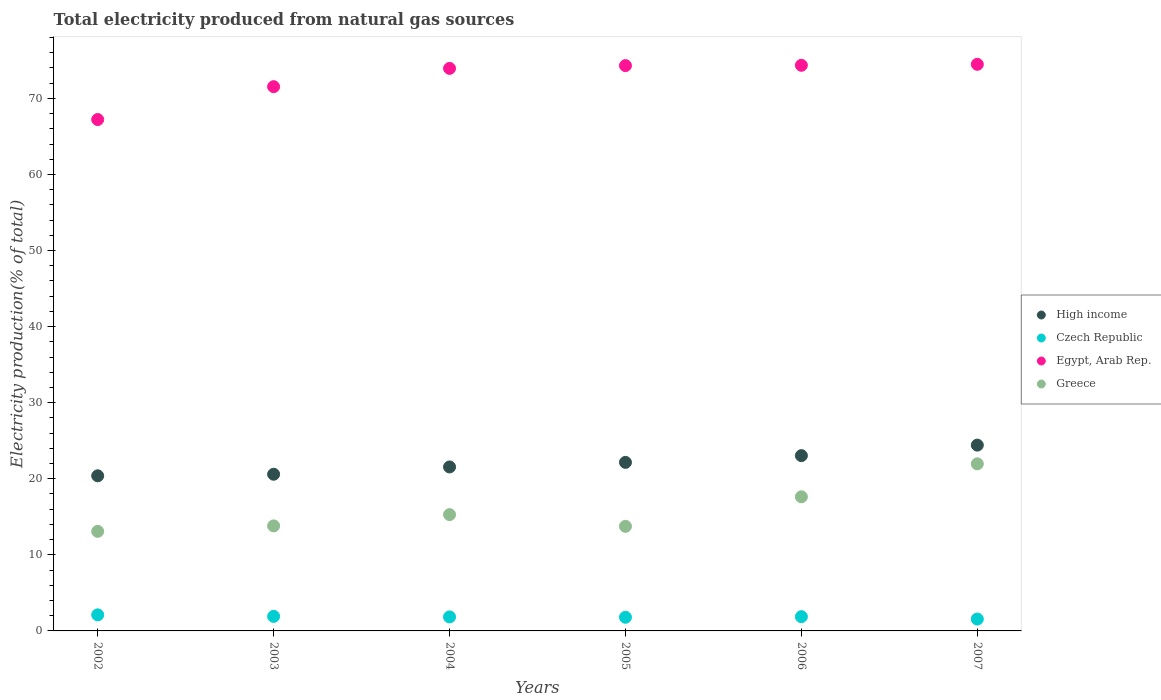What is the total electricity produced in Czech Republic in 2006?
Give a very brief answer. 1.87. Across all years, what is the maximum total electricity produced in High income?
Your response must be concise. 24.42. Across all years, what is the minimum total electricity produced in Czech Republic?
Keep it short and to the point. 1.56. In which year was the total electricity produced in High income maximum?
Offer a very short reply. 2007. In which year was the total electricity produced in Egypt, Arab Rep. minimum?
Ensure brevity in your answer.  2002. What is the total total electricity produced in Greece in the graph?
Offer a terse response. 95.53. What is the difference between the total electricity produced in Egypt, Arab Rep. in 2003 and that in 2004?
Your answer should be very brief. -2.4. What is the difference between the total electricity produced in Czech Republic in 2002 and the total electricity produced in Greece in 2005?
Your response must be concise. -11.64. What is the average total electricity produced in Greece per year?
Ensure brevity in your answer.  15.92. In the year 2003, what is the difference between the total electricity produced in Czech Republic and total electricity produced in High income?
Your response must be concise. -18.68. In how many years, is the total electricity produced in Greece greater than 58 %?
Ensure brevity in your answer.  0. What is the ratio of the total electricity produced in High income in 2003 to that in 2005?
Ensure brevity in your answer.  0.93. Is the total electricity produced in Czech Republic in 2003 less than that in 2004?
Offer a terse response. No. Is the difference between the total electricity produced in Czech Republic in 2002 and 2004 greater than the difference between the total electricity produced in High income in 2002 and 2004?
Give a very brief answer. Yes. What is the difference between the highest and the second highest total electricity produced in Czech Republic?
Provide a short and direct response. 0.2. What is the difference between the highest and the lowest total electricity produced in Greece?
Offer a very short reply. 8.87. In how many years, is the total electricity produced in High income greater than the average total electricity produced in High income taken over all years?
Provide a short and direct response. 3. Is the sum of the total electricity produced in High income in 2003 and 2007 greater than the maximum total electricity produced in Czech Republic across all years?
Give a very brief answer. Yes. Is it the case that in every year, the sum of the total electricity produced in High income and total electricity produced in Czech Republic  is greater than the total electricity produced in Greece?
Provide a short and direct response. Yes. Is the total electricity produced in High income strictly less than the total electricity produced in Greece over the years?
Make the answer very short. No. How many years are there in the graph?
Your response must be concise. 6. What is the difference between two consecutive major ticks on the Y-axis?
Make the answer very short. 10. Are the values on the major ticks of Y-axis written in scientific E-notation?
Offer a very short reply. No. Does the graph contain any zero values?
Your answer should be very brief. No. Where does the legend appear in the graph?
Keep it short and to the point. Center right. How many legend labels are there?
Offer a terse response. 4. How are the legend labels stacked?
Your answer should be compact. Vertical. What is the title of the graph?
Your answer should be very brief. Total electricity produced from natural gas sources. What is the label or title of the X-axis?
Offer a very short reply. Years. What is the Electricity production(% of total) in High income in 2002?
Your answer should be compact. 20.39. What is the Electricity production(% of total) of Czech Republic in 2002?
Provide a short and direct response. 2.11. What is the Electricity production(% of total) of Egypt, Arab Rep. in 2002?
Your response must be concise. 67.22. What is the Electricity production(% of total) of Greece in 2002?
Your answer should be compact. 13.09. What is the Electricity production(% of total) in High income in 2003?
Make the answer very short. 20.59. What is the Electricity production(% of total) of Czech Republic in 2003?
Provide a succinct answer. 1.91. What is the Electricity production(% of total) in Egypt, Arab Rep. in 2003?
Ensure brevity in your answer.  71.54. What is the Electricity production(% of total) in Greece in 2003?
Make the answer very short. 13.81. What is the Electricity production(% of total) of High income in 2004?
Offer a terse response. 21.55. What is the Electricity production(% of total) in Czech Republic in 2004?
Your answer should be compact. 1.84. What is the Electricity production(% of total) in Egypt, Arab Rep. in 2004?
Provide a succinct answer. 73.94. What is the Electricity production(% of total) in Greece in 2004?
Give a very brief answer. 15.29. What is the Electricity production(% of total) in High income in 2005?
Your response must be concise. 22.16. What is the Electricity production(% of total) of Czech Republic in 2005?
Your response must be concise. 1.79. What is the Electricity production(% of total) of Egypt, Arab Rep. in 2005?
Provide a succinct answer. 74.31. What is the Electricity production(% of total) in Greece in 2005?
Provide a short and direct response. 13.75. What is the Electricity production(% of total) in High income in 2006?
Offer a terse response. 23.04. What is the Electricity production(% of total) of Czech Republic in 2006?
Make the answer very short. 1.87. What is the Electricity production(% of total) in Egypt, Arab Rep. in 2006?
Keep it short and to the point. 74.35. What is the Electricity production(% of total) of Greece in 2006?
Give a very brief answer. 17.63. What is the Electricity production(% of total) in High income in 2007?
Your answer should be very brief. 24.42. What is the Electricity production(% of total) in Czech Republic in 2007?
Offer a terse response. 1.56. What is the Electricity production(% of total) of Egypt, Arab Rep. in 2007?
Ensure brevity in your answer.  74.48. What is the Electricity production(% of total) in Greece in 2007?
Your answer should be compact. 21.96. Across all years, what is the maximum Electricity production(% of total) of High income?
Make the answer very short. 24.42. Across all years, what is the maximum Electricity production(% of total) of Czech Republic?
Offer a terse response. 2.11. Across all years, what is the maximum Electricity production(% of total) in Egypt, Arab Rep.?
Provide a succinct answer. 74.48. Across all years, what is the maximum Electricity production(% of total) of Greece?
Offer a very short reply. 21.96. Across all years, what is the minimum Electricity production(% of total) in High income?
Keep it short and to the point. 20.39. Across all years, what is the minimum Electricity production(% of total) of Czech Republic?
Ensure brevity in your answer.  1.56. Across all years, what is the minimum Electricity production(% of total) in Egypt, Arab Rep.?
Ensure brevity in your answer.  67.22. Across all years, what is the minimum Electricity production(% of total) in Greece?
Offer a very short reply. 13.09. What is the total Electricity production(% of total) of High income in the graph?
Your answer should be very brief. 132.16. What is the total Electricity production(% of total) of Czech Republic in the graph?
Keep it short and to the point. 11.09. What is the total Electricity production(% of total) of Egypt, Arab Rep. in the graph?
Make the answer very short. 435.85. What is the total Electricity production(% of total) in Greece in the graph?
Your response must be concise. 95.53. What is the difference between the Electricity production(% of total) of High income in 2002 and that in 2003?
Your response must be concise. -0.2. What is the difference between the Electricity production(% of total) in Czech Republic in 2002 and that in 2003?
Provide a short and direct response. 0.2. What is the difference between the Electricity production(% of total) of Egypt, Arab Rep. in 2002 and that in 2003?
Offer a terse response. -4.32. What is the difference between the Electricity production(% of total) of Greece in 2002 and that in 2003?
Your answer should be compact. -0.72. What is the difference between the Electricity production(% of total) in High income in 2002 and that in 2004?
Offer a terse response. -1.16. What is the difference between the Electricity production(% of total) of Czech Republic in 2002 and that in 2004?
Your response must be concise. 0.27. What is the difference between the Electricity production(% of total) of Egypt, Arab Rep. in 2002 and that in 2004?
Offer a very short reply. -6.72. What is the difference between the Electricity production(% of total) in Greece in 2002 and that in 2004?
Offer a very short reply. -2.2. What is the difference between the Electricity production(% of total) of High income in 2002 and that in 2005?
Your answer should be compact. -1.77. What is the difference between the Electricity production(% of total) of Czech Republic in 2002 and that in 2005?
Offer a terse response. 0.32. What is the difference between the Electricity production(% of total) of Egypt, Arab Rep. in 2002 and that in 2005?
Offer a very short reply. -7.09. What is the difference between the Electricity production(% of total) in Greece in 2002 and that in 2005?
Offer a very short reply. -0.66. What is the difference between the Electricity production(% of total) in High income in 2002 and that in 2006?
Ensure brevity in your answer.  -2.65. What is the difference between the Electricity production(% of total) in Czech Republic in 2002 and that in 2006?
Ensure brevity in your answer.  0.24. What is the difference between the Electricity production(% of total) in Egypt, Arab Rep. in 2002 and that in 2006?
Give a very brief answer. -7.13. What is the difference between the Electricity production(% of total) in Greece in 2002 and that in 2006?
Give a very brief answer. -4.54. What is the difference between the Electricity production(% of total) in High income in 2002 and that in 2007?
Offer a very short reply. -4.03. What is the difference between the Electricity production(% of total) in Czech Republic in 2002 and that in 2007?
Provide a short and direct response. 0.55. What is the difference between the Electricity production(% of total) in Egypt, Arab Rep. in 2002 and that in 2007?
Give a very brief answer. -7.26. What is the difference between the Electricity production(% of total) in Greece in 2002 and that in 2007?
Make the answer very short. -8.88. What is the difference between the Electricity production(% of total) of High income in 2003 and that in 2004?
Give a very brief answer. -0.96. What is the difference between the Electricity production(% of total) of Czech Republic in 2003 and that in 2004?
Ensure brevity in your answer.  0.07. What is the difference between the Electricity production(% of total) of Egypt, Arab Rep. in 2003 and that in 2004?
Your response must be concise. -2.4. What is the difference between the Electricity production(% of total) of Greece in 2003 and that in 2004?
Your answer should be compact. -1.48. What is the difference between the Electricity production(% of total) of High income in 2003 and that in 2005?
Provide a short and direct response. -1.56. What is the difference between the Electricity production(% of total) of Czech Republic in 2003 and that in 2005?
Offer a very short reply. 0.12. What is the difference between the Electricity production(% of total) of Egypt, Arab Rep. in 2003 and that in 2005?
Provide a succinct answer. -2.77. What is the difference between the Electricity production(% of total) of Greece in 2003 and that in 2005?
Give a very brief answer. 0.06. What is the difference between the Electricity production(% of total) in High income in 2003 and that in 2006?
Ensure brevity in your answer.  -2.45. What is the difference between the Electricity production(% of total) in Czech Republic in 2003 and that in 2006?
Your answer should be compact. 0.04. What is the difference between the Electricity production(% of total) of Egypt, Arab Rep. in 2003 and that in 2006?
Offer a terse response. -2.81. What is the difference between the Electricity production(% of total) of Greece in 2003 and that in 2006?
Ensure brevity in your answer.  -3.82. What is the difference between the Electricity production(% of total) of High income in 2003 and that in 2007?
Keep it short and to the point. -3.83. What is the difference between the Electricity production(% of total) in Czech Republic in 2003 and that in 2007?
Offer a very short reply. 0.35. What is the difference between the Electricity production(% of total) of Egypt, Arab Rep. in 2003 and that in 2007?
Keep it short and to the point. -2.94. What is the difference between the Electricity production(% of total) of Greece in 2003 and that in 2007?
Your response must be concise. -8.16. What is the difference between the Electricity production(% of total) in High income in 2004 and that in 2005?
Make the answer very short. -0.6. What is the difference between the Electricity production(% of total) of Czech Republic in 2004 and that in 2005?
Offer a very short reply. 0.05. What is the difference between the Electricity production(% of total) of Egypt, Arab Rep. in 2004 and that in 2005?
Your response must be concise. -0.36. What is the difference between the Electricity production(% of total) of Greece in 2004 and that in 2005?
Your response must be concise. 1.54. What is the difference between the Electricity production(% of total) of High income in 2004 and that in 2006?
Make the answer very short. -1.49. What is the difference between the Electricity production(% of total) of Czech Republic in 2004 and that in 2006?
Provide a succinct answer. -0.03. What is the difference between the Electricity production(% of total) in Egypt, Arab Rep. in 2004 and that in 2006?
Ensure brevity in your answer.  -0.41. What is the difference between the Electricity production(% of total) of Greece in 2004 and that in 2006?
Keep it short and to the point. -2.34. What is the difference between the Electricity production(% of total) in High income in 2004 and that in 2007?
Your response must be concise. -2.87. What is the difference between the Electricity production(% of total) in Czech Republic in 2004 and that in 2007?
Your answer should be very brief. 0.28. What is the difference between the Electricity production(% of total) in Egypt, Arab Rep. in 2004 and that in 2007?
Ensure brevity in your answer.  -0.54. What is the difference between the Electricity production(% of total) of Greece in 2004 and that in 2007?
Your answer should be compact. -6.68. What is the difference between the Electricity production(% of total) in High income in 2005 and that in 2006?
Make the answer very short. -0.89. What is the difference between the Electricity production(% of total) of Czech Republic in 2005 and that in 2006?
Offer a very short reply. -0.08. What is the difference between the Electricity production(% of total) of Egypt, Arab Rep. in 2005 and that in 2006?
Offer a very short reply. -0.04. What is the difference between the Electricity production(% of total) of Greece in 2005 and that in 2006?
Offer a very short reply. -3.88. What is the difference between the Electricity production(% of total) in High income in 2005 and that in 2007?
Your answer should be compact. -2.27. What is the difference between the Electricity production(% of total) in Czech Republic in 2005 and that in 2007?
Your answer should be compact. 0.23. What is the difference between the Electricity production(% of total) in Egypt, Arab Rep. in 2005 and that in 2007?
Your response must be concise. -0.17. What is the difference between the Electricity production(% of total) in Greece in 2005 and that in 2007?
Provide a succinct answer. -8.21. What is the difference between the Electricity production(% of total) in High income in 2006 and that in 2007?
Offer a terse response. -1.38. What is the difference between the Electricity production(% of total) of Czech Republic in 2006 and that in 2007?
Your answer should be very brief. 0.31. What is the difference between the Electricity production(% of total) of Egypt, Arab Rep. in 2006 and that in 2007?
Offer a terse response. -0.13. What is the difference between the Electricity production(% of total) in Greece in 2006 and that in 2007?
Ensure brevity in your answer.  -4.33. What is the difference between the Electricity production(% of total) in High income in 2002 and the Electricity production(% of total) in Czech Republic in 2003?
Keep it short and to the point. 18.48. What is the difference between the Electricity production(% of total) of High income in 2002 and the Electricity production(% of total) of Egypt, Arab Rep. in 2003?
Keep it short and to the point. -51.15. What is the difference between the Electricity production(% of total) of High income in 2002 and the Electricity production(% of total) of Greece in 2003?
Your response must be concise. 6.58. What is the difference between the Electricity production(% of total) of Czech Republic in 2002 and the Electricity production(% of total) of Egypt, Arab Rep. in 2003?
Your answer should be very brief. -69.43. What is the difference between the Electricity production(% of total) in Czech Republic in 2002 and the Electricity production(% of total) in Greece in 2003?
Make the answer very short. -11.7. What is the difference between the Electricity production(% of total) in Egypt, Arab Rep. in 2002 and the Electricity production(% of total) in Greece in 2003?
Your answer should be very brief. 53.41. What is the difference between the Electricity production(% of total) of High income in 2002 and the Electricity production(% of total) of Czech Republic in 2004?
Your response must be concise. 18.55. What is the difference between the Electricity production(% of total) in High income in 2002 and the Electricity production(% of total) in Egypt, Arab Rep. in 2004?
Offer a very short reply. -53.55. What is the difference between the Electricity production(% of total) of High income in 2002 and the Electricity production(% of total) of Greece in 2004?
Your answer should be very brief. 5.1. What is the difference between the Electricity production(% of total) of Czech Republic in 2002 and the Electricity production(% of total) of Egypt, Arab Rep. in 2004?
Offer a terse response. -71.83. What is the difference between the Electricity production(% of total) of Czech Republic in 2002 and the Electricity production(% of total) of Greece in 2004?
Offer a terse response. -13.18. What is the difference between the Electricity production(% of total) of Egypt, Arab Rep. in 2002 and the Electricity production(% of total) of Greece in 2004?
Your answer should be very brief. 51.93. What is the difference between the Electricity production(% of total) in High income in 2002 and the Electricity production(% of total) in Czech Republic in 2005?
Give a very brief answer. 18.6. What is the difference between the Electricity production(% of total) in High income in 2002 and the Electricity production(% of total) in Egypt, Arab Rep. in 2005?
Your answer should be very brief. -53.92. What is the difference between the Electricity production(% of total) of High income in 2002 and the Electricity production(% of total) of Greece in 2005?
Your response must be concise. 6.64. What is the difference between the Electricity production(% of total) of Czech Republic in 2002 and the Electricity production(% of total) of Egypt, Arab Rep. in 2005?
Ensure brevity in your answer.  -72.2. What is the difference between the Electricity production(% of total) in Czech Republic in 2002 and the Electricity production(% of total) in Greece in 2005?
Ensure brevity in your answer.  -11.64. What is the difference between the Electricity production(% of total) of Egypt, Arab Rep. in 2002 and the Electricity production(% of total) of Greece in 2005?
Provide a short and direct response. 53.47. What is the difference between the Electricity production(% of total) in High income in 2002 and the Electricity production(% of total) in Czech Republic in 2006?
Your response must be concise. 18.52. What is the difference between the Electricity production(% of total) in High income in 2002 and the Electricity production(% of total) in Egypt, Arab Rep. in 2006?
Make the answer very short. -53.96. What is the difference between the Electricity production(% of total) in High income in 2002 and the Electricity production(% of total) in Greece in 2006?
Provide a short and direct response. 2.76. What is the difference between the Electricity production(% of total) in Czech Republic in 2002 and the Electricity production(% of total) in Egypt, Arab Rep. in 2006?
Your answer should be very brief. -72.24. What is the difference between the Electricity production(% of total) of Czech Republic in 2002 and the Electricity production(% of total) of Greece in 2006?
Offer a terse response. -15.52. What is the difference between the Electricity production(% of total) of Egypt, Arab Rep. in 2002 and the Electricity production(% of total) of Greece in 2006?
Your response must be concise. 49.59. What is the difference between the Electricity production(% of total) of High income in 2002 and the Electricity production(% of total) of Czech Republic in 2007?
Provide a succinct answer. 18.83. What is the difference between the Electricity production(% of total) in High income in 2002 and the Electricity production(% of total) in Egypt, Arab Rep. in 2007?
Your response must be concise. -54.09. What is the difference between the Electricity production(% of total) in High income in 2002 and the Electricity production(% of total) in Greece in 2007?
Provide a short and direct response. -1.57. What is the difference between the Electricity production(% of total) in Czech Republic in 2002 and the Electricity production(% of total) in Egypt, Arab Rep. in 2007?
Your response must be concise. -72.37. What is the difference between the Electricity production(% of total) of Czech Republic in 2002 and the Electricity production(% of total) of Greece in 2007?
Your answer should be very brief. -19.85. What is the difference between the Electricity production(% of total) of Egypt, Arab Rep. in 2002 and the Electricity production(% of total) of Greece in 2007?
Make the answer very short. 45.26. What is the difference between the Electricity production(% of total) of High income in 2003 and the Electricity production(% of total) of Czech Republic in 2004?
Your answer should be compact. 18.75. What is the difference between the Electricity production(% of total) of High income in 2003 and the Electricity production(% of total) of Egypt, Arab Rep. in 2004?
Give a very brief answer. -53.35. What is the difference between the Electricity production(% of total) of High income in 2003 and the Electricity production(% of total) of Greece in 2004?
Keep it short and to the point. 5.31. What is the difference between the Electricity production(% of total) of Czech Republic in 2003 and the Electricity production(% of total) of Egypt, Arab Rep. in 2004?
Provide a succinct answer. -72.03. What is the difference between the Electricity production(% of total) in Czech Republic in 2003 and the Electricity production(% of total) in Greece in 2004?
Offer a terse response. -13.37. What is the difference between the Electricity production(% of total) of Egypt, Arab Rep. in 2003 and the Electricity production(% of total) of Greece in 2004?
Ensure brevity in your answer.  56.25. What is the difference between the Electricity production(% of total) in High income in 2003 and the Electricity production(% of total) in Czech Republic in 2005?
Provide a short and direct response. 18.8. What is the difference between the Electricity production(% of total) of High income in 2003 and the Electricity production(% of total) of Egypt, Arab Rep. in 2005?
Your answer should be very brief. -53.71. What is the difference between the Electricity production(% of total) in High income in 2003 and the Electricity production(% of total) in Greece in 2005?
Your response must be concise. 6.85. What is the difference between the Electricity production(% of total) in Czech Republic in 2003 and the Electricity production(% of total) in Egypt, Arab Rep. in 2005?
Give a very brief answer. -72.4. What is the difference between the Electricity production(% of total) in Czech Republic in 2003 and the Electricity production(% of total) in Greece in 2005?
Offer a very short reply. -11.84. What is the difference between the Electricity production(% of total) of Egypt, Arab Rep. in 2003 and the Electricity production(% of total) of Greece in 2005?
Give a very brief answer. 57.79. What is the difference between the Electricity production(% of total) in High income in 2003 and the Electricity production(% of total) in Czech Republic in 2006?
Keep it short and to the point. 18.72. What is the difference between the Electricity production(% of total) in High income in 2003 and the Electricity production(% of total) in Egypt, Arab Rep. in 2006?
Ensure brevity in your answer.  -53.76. What is the difference between the Electricity production(% of total) of High income in 2003 and the Electricity production(% of total) of Greece in 2006?
Your answer should be very brief. 2.96. What is the difference between the Electricity production(% of total) in Czech Republic in 2003 and the Electricity production(% of total) in Egypt, Arab Rep. in 2006?
Make the answer very short. -72.44. What is the difference between the Electricity production(% of total) in Czech Republic in 2003 and the Electricity production(% of total) in Greece in 2006?
Make the answer very short. -15.72. What is the difference between the Electricity production(% of total) in Egypt, Arab Rep. in 2003 and the Electricity production(% of total) in Greece in 2006?
Your answer should be compact. 53.91. What is the difference between the Electricity production(% of total) of High income in 2003 and the Electricity production(% of total) of Czech Republic in 2007?
Make the answer very short. 19.03. What is the difference between the Electricity production(% of total) of High income in 2003 and the Electricity production(% of total) of Egypt, Arab Rep. in 2007?
Keep it short and to the point. -53.89. What is the difference between the Electricity production(% of total) in High income in 2003 and the Electricity production(% of total) in Greece in 2007?
Give a very brief answer. -1.37. What is the difference between the Electricity production(% of total) in Czech Republic in 2003 and the Electricity production(% of total) in Egypt, Arab Rep. in 2007?
Offer a very short reply. -72.57. What is the difference between the Electricity production(% of total) in Czech Republic in 2003 and the Electricity production(% of total) in Greece in 2007?
Keep it short and to the point. -20.05. What is the difference between the Electricity production(% of total) in Egypt, Arab Rep. in 2003 and the Electricity production(% of total) in Greece in 2007?
Provide a succinct answer. 49.58. What is the difference between the Electricity production(% of total) in High income in 2004 and the Electricity production(% of total) in Czech Republic in 2005?
Offer a terse response. 19.76. What is the difference between the Electricity production(% of total) in High income in 2004 and the Electricity production(% of total) in Egypt, Arab Rep. in 2005?
Your response must be concise. -52.75. What is the difference between the Electricity production(% of total) of High income in 2004 and the Electricity production(% of total) of Greece in 2005?
Ensure brevity in your answer.  7.8. What is the difference between the Electricity production(% of total) of Czech Republic in 2004 and the Electricity production(% of total) of Egypt, Arab Rep. in 2005?
Give a very brief answer. -72.47. What is the difference between the Electricity production(% of total) of Czech Republic in 2004 and the Electricity production(% of total) of Greece in 2005?
Give a very brief answer. -11.91. What is the difference between the Electricity production(% of total) of Egypt, Arab Rep. in 2004 and the Electricity production(% of total) of Greece in 2005?
Your answer should be very brief. 60.19. What is the difference between the Electricity production(% of total) of High income in 2004 and the Electricity production(% of total) of Czech Republic in 2006?
Give a very brief answer. 19.68. What is the difference between the Electricity production(% of total) of High income in 2004 and the Electricity production(% of total) of Egypt, Arab Rep. in 2006?
Ensure brevity in your answer.  -52.8. What is the difference between the Electricity production(% of total) in High income in 2004 and the Electricity production(% of total) in Greece in 2006?
Make the answer very short. 3.92. What is the difference between the Electricity production(% of total) of Czech Republic in 2004 and the Electricity production(% of total) of Egypt, Arab Rep. in 2006?
Offer a very short reply. -72.51. What is the difference between the Electricity production(% of total) in Czech Republic in 2004 and the Electricity production(% of total) in Greece in 2006?
Make the answer very short. -15.79. What is the difference between the Electricity production(% of total) of Egypt, Arab Rep. in 2004 and the Electricity production(% of total) of Greece in 2006?
Give a very brief answer. 56.31. What is the difference between the Electricity production(% of total) in High income in 2004 and the Electricity production(% of total) in Czech Republic in 2007?
Provide a succinct answer. 19.99. What is the difference between the Electricity production(% of total) in High income in 2004 and the Electricity production(% of total) in Egypt, Arab Rep. in 2007?
Offer a very short reply. -52.93. What is the difference between the Electricity production(% of total) in High income in 2004 and the Electricity production(% of total) in Greece in 2007?
Offer a very short reply. -0.41. What is the difference between the Electricity production(% of total) in Czech Republic in 2004 and the Electricity production(% of total) in Egypt, Arab Rep. in 2007?
Provide a succinct answer. -72.64. What is the difference between the Electricity production(% of total) of Czech Republic in 2004 and the Electricity production(% of total) of Greece in 2007?
Your response must be concise. -20.12. What is the difference between the Electricity production(% of total) in Egypt, Arab Rep. in 2004 and the Electricity production(% of total) in Greece in 2007?
Your answer should be compact. 51.98. What is the difference between the Electricity production(% of total) of High income in 2005 and the Electricity production(% of total) of Czech Republic in 2006?
Keep it short and to the point. 20.28. What is the difference between the Electricity production(% of total) of High income in 2005 and the Electricity production(% of total) of Egypt, Arab Rep. in 2006?
Offer a terse response. -52.2. What is the difference between the Electricity production(% of total) in High income in 2005 and the Electricity production(% of total) in Greece in 2006?
Your answer should be very brief. 4.52. What is the difference between the Electricity production(% of total) of Czech Republic in 2005 and the Electricity production(% of total) of Egypt, Arab Rep. in 2006?
Keep it short and to the point. -72.56. What is the difference between the Electricity production(% of total) of Czech Republic in 2005 and the Electricity production(% of total) of Greece in 2006?
Ensure brevity in your answer.  -15.84. What is the difference between the Electricity production(% of total) of Egypt, Arab Rep. in 2005 and the Electricity production(% of total) of Greece in 2006?
Offer a very short reply. 56.68. What is the difference between the Electricity production(% of total) in High income in 2005 and the Electricity production(% of total) in Czech Republic in 2007?
Your response must be concise. 20.59. What is the difference between the Electricity production(% of total) in High income in 2005 and the Electricity production(% of total) in Egypt, Arab Rep. in 2007?
Make the answer very short. -52.33. What is the difference between the Electricity production(% of total) in High income in 2005 and the Electricity production(% of total) in Greece in 2007?
Make the answer very short. 0.19. What is the difference between the Electricity production(% of total) of Czech Republic in 2005 and the Electricity production(% of total) of Egypt, Arab Rep. in 2007?
Keep it short and to the point. -72.69. What is the difference between the Electricity production(% of total) of Czech Republic in 2005 and the Electricity production(% of total) of Greece in 2007?
Your response must be concise. -20.17. What is the difference between the Electricity production(% of total) of Egypt, Arab Rep. in 2005 and the Electricity production(% of total) of Greece in 2007?
Offer a terse response. 52.34. What is the difference between the Electricity production(% of total) of High income in 2006 and the Electricity production(% of total) of Czech Republic in 2007?
Offer a very short reply. 21.48. What is the difference between the Electricity production(% of total) in High income in 2006 and the Electricity production(% of total) in Egypt, Arab Rep. in 2007?
Your answer should be compact. -51.44. What is the difference between the Electricity production(% of total) in High income in 2006 and the Electricity production(% of total) in Greece in 2007?
Keep it short and to the point. 1.08. What is the difference between the Electricity production(% of total) in Czech Republic in 2006 and the Electricity production(% of total) in Egypt, Arab Rep. in 2007?
Keep it short and to the point. -72.61. What is the difference between the Electricity production(% of total) of Czech Republic in 2006 and the Electricity production(% of total) of Greece in 2007?
Give a very brief answer. -20.09. What is the difference between the Electricity production(% of total) of Egypt, Arab Rep. in 2006 and the Electricity production(% of total) of Greece in 2007?
Offer a very short reply. 52.39. What is the average Electricity production(% of total) of High income per year?
Your response must be concise. 22.03. What is the average Electricity production(% of total) of Czech Republic per year?
Give a very brief answer. 1.85. What is the average Electricity production(% of total) in Egypt, Arab Rep. per year?
Offer a terse response. 72.64. What is the average Electricity production(% of total) in Greece per year?
Your answer should be compact. 15.92. In the year 2002, what is the difference between the Electricity production(% of total) in High income and Electricity production(% of total) in Czech Republic?
Provide a succinct answer. 18.28. In the year 2002, what is the difference between the Electricity production(% of total) in High income and Electricity production(% of total) in Egypt, Arab Rep.?
Offer a very short reply. -46.83. In the year 2002, what is the difference between the Electricity production(% of total) in High income and Electricity production(% of total) in Greece?
Your answer should be very brief. 7.3. In the year 2002, what is the difference between the Electricity production(% of total) in Czech Republic and Electricity production(% of total) in Egypt, Arab Rep.?
Offer a terse response. -65.11. In the year 2002, what is the difference between the Electricity production(% of total) in Czech Republic and Electricity production(% of total) in Greece?
Your answer should be very brief. -10.98. In the year 2002, what is the difference between the Electricity production(% of total) in Egypt, Arab Rep. and Electricity production(% of total) in Greece?
Make the answer very short. 54.13. In the year 2003, what is the difference between the Electricity production(% of total) of High income and Electricity production(% of total) of Czech Republic?
Ensure brevity in your answer.  18.68. In the year 2003, what is the difference between the Electricity production(% of total) in High income and Electricity production(% of total) in Egypt, Arab Rep.?
Offer a very short reply. -50.95. In the year 2003, what is the difference between the Electricity production(% of total) in High income and Electricity production(% of total) in Greece?
Offer a very short reply. 6.79. In the year 2003, what is the difference between the Electricity production(% of total) in Czech Republic and Electricity production(% of total) in Egypt, Arab Rep.?
Keep it short and to the point. -69.63. In the year 2003, what is the difference between the Electricity production(% of total) of Czech Republic and Electricity production(% of total) of Greece?
Provide a short and direct response. -11.89. In the year 2003, what is the difference between the Electricity production(% of total) of Egypt, Arab Rep. and Electricity production(% of total) of Greece?
Provide a succinct answer. 57.74. In the year 2004, what is the difference between the Electricity production(% of total) of High income and Electricity production(% of total) of Czech Republic?
Provide a short and direct response. 19.71. In the year 2004, what is the difference between the Electricity production(% of total) of High income and Electricity production(% of total) of Egypt, Arab Rep.?
Offer a terse response. -52.39. In the year 2004, what is the difference between the Electricity production(% of total) in High income and Electricity production(% of total) in Greece?
Ensure brevity in your answer.  6.27. In the year 2004, what is the difference between the Electricity production(% of total) of Czech Republic and Electricity production(% of total) of Egypt, Arab Rep.?
Your answer should be very brief. -72.1. In the year 2004, what is the difference between the Electricity production(% of total) of Czech Republic and Electricity production(% of total) of Greece?
Give a very brief answer. -13.45. In the year 2004, what is the difference between the Electricity production(% of total) of Egypt, Arab Rep. and Electricity production(% of total) of Greece?
Ensure brevity in your answer.  58.66. In the year 2005, what is the difference between the Electricity production(% of total) in High income and Electricity production(% of total) in Czech Republic?
Offer a terse response. 20.36. In the year 2005, what is the difference between the Electricity production(% of total) of High income and Electricity production(% of total) of Egypt, Arab Rep.?
Make the answer very short. -52.15. In the year 2005, what is the difference between the Electricity production(% of total) of High income and Electricity production(% of total) of Greece?
Give a very brief answer. 8.41. In the year 2005, what is the difference between the Electricity production(% of total) in Czech Republic and Electricity production(% of total) in Egypt, Arab Rep.?
Provide a succinct answer. -72.51. In the year 2005, what is the difference between the Electricity production(% of total) in Czech Republic and Electricity production(% of total) in Greece?
Keep it short and to the point. -11.96. In the year 2005, what is the difference between the Electricity production(% of total) of Egypt, Arab Rep. and Electricity production(% of total) of Greece?
Your answer should be very brief. 60.56. In the year 2006, what is the difference between the Electricity production(% of total) of High income and Electricity production(% of total) of Czech Republic?
Your answer should be very brief. 21.17. In the year 2006, what is the difference between the Electricity production(% of total) of High income and Electricity production(% of total) of Egypt, Arab Rep.?
Ensure brevity in your answer.  -51.31. In the year 2006, what is the difference between the Electricity production(% of total) of High income and Electricity production(% of total) of Greece?
Keep it short and to the point. 5.41. In the year 2006, what is the difference between the Electricity production(% of total) in Czech Republic and Electricity production(% of total) in Egypt, Arab Rep.?
Your answer should be very brief. -72.48. In the year 2006, what is the difference between the Electricity production(% of total) in Czech Republic and Electricity production(% of total) in Greece?
Make the answer very short. -15.76. In the year 2006, what is the difference between the Electricity production(% of total) of Egypt, Arab Rep. and Electricity production(% of total) of Greece?
Ensure brevity in your answer.  56.72. In the year 2007, what is the difference between the Electricity production(% of total) in High income and Electricity production(% of total) in Czech Republic?
Your response must be concise. 22.86. In the year 2007, what is the difference between the Electricity production(% of total) in High income and Electricity production(% of total) in Egypt, Arab Rep.?
Offer a terse response. -50.06. In the year 2007, what is the difference between the Electricity production(% of total) in High income and Electricity production(% of total) in Greece?
Your answer should be compact. 2.46. In the year 2007, what is the difference between the Electricity production(% of total) in Czech Republic and Electricity production(% of total) in Egypt, Arab Rep.?
Provide a short and direct response. -72.92. In the year 2007, what is the difference between the Electricity production(% of total) of Czech Republic and Electricity production(% of total) of Greece?
Your answer should be very brief. -20.4. In the year 2007, what is the difference between the Electricity production(% of total) of Egypt, Arab Rep. and Electricity production(% of total) of Greece?
Provide a succinct answer. 52.52. What is the ratio of the Electricity production(% of total) in Czech Republic in 2002 to that in 2003?
Give a very brief answer. 1.1. What is the ratio of the Electricity production(% of total) in Egypt, Arab Rep. in 2002 to that in 2003?
Give a very brief answer. 0.94. What is the ratio of the Electricity production(% of total) in Greece in 2002 to that in 2003?
Give a very brief answer. 0.95. What is the ratio of the Electricity production(% of total) in High income in 2002 to that in 2004?
Make the answer very short. 0.95. What is the ratio of the Electricity production(% of total) of Czech Republic in 2002 to that in 2004?
Ensure brevity in your answer.  1.15. What is the ratio of the Electricity production(% of total) of Egypt, Arab Rep. in 2002 to that in 2004?
Your answer should be compact. 0.91. What is the ratio of the Electricity production(% of total) of Greece in 2002 to that in 2004?
Offer a very short reply. 0.86. What is the ratio of the Electricity production(% of total) in High income in 2002 to that in 2005?
Your answer should be compact. 0.92. What is the ratio of the Electricity production(% of total) of Czech Republic in 2002 to that in 2005?
Provide a succinct answer. 1.18. What is the ratio of the Electricity production(% of total) of Egypt, Arab Rep. in 2002 to that in 2005?
Offer a very short reply. 0.9. What is the ratio of the Electricity production(% of total) in Greece in 2002 to that in 2005?
Your response must be concise. 0.95. What is the ratio of the Electricity production(% of total) of High income in 2002 to that in 2006?
Ensure brevity in your answer.  0.88. What is the ratio of the Electricity production(% of total) in Czech Republic in 2002 to that in 2006?
Keep it short and to the point. 1.13. What is the ratio of the Electricity production(% of total) in Egypt, Arab Rep. in 2002 to that in 2006?
Make the answer very short. 0.9. What is the ratio of the Electricity production(% of total) in Greece in 2002 to that in 2006?
Provide a short and direct response. 0.74. What is the ratio of the Electricity production(% of total) in High income in 2002 to that in 2007?
Provide a succinct answer. 0.83. What is the ratio of the Electricity production(% of total) of Czech Republic in 2002 to that in 2007?
Ensure brevity in your answer.  1.35. What is the ratio of the Electricity production(% of total) in Egypt, Arab Rep. in 2002 to that in 2007?
Provide a short and direct response. 0.9. What is the ratio of the Electricity production(% of total) of Greece in 2002 to that in 2007?
Provide a short and direct response. 0.6. What is the ratio of the Electricity production(% of total) of High income in 2003 to that in 2004?
Provide a short and direct response. 0.96. What is the ratio of the Electricity production(% of total) of Czech Republic in 2003 to that in 2004?
Provide a short and direct response. 1.04. What is the ratio of the Electricity production(% of total) of Egypt, Arab Rep. in 2003 to that in 2004?
Provide a short and direct response. 0.97. What is the ratio of the Electricity production(% of total) in Greece in 2003 to that in 2004?
Offer a terse response. 0.9. What is the ratio of the Electricity production(% of total) of High income in 2003 to that in 2005?
Ensure brevity in your answer.  0.93. What is the ratio of the Electricity production(% of total) of Czech Republic in 2003 to that in 2005?
Make the answer very short. 1.07. What is the ratio of the Electricity production(% of total) of Egypt, Arab Rep. in 2003 to that in 2005?
Provide a short and direct response. 0.96. What is the ratio of the Electricity production(% of total) of High income in 2003 to that in 2006?
Offer a terse response. 0.89. What is the ratio of the Electricity production(% of total) in Czech Republic in 2003 to that in 2006?
Offer a terse response. 1.02. What is the ratio of the Electricity production(% of total) in Egypt, Arab Rep. in 2003 to that in 2006?
Your response must be concise. 0.96. What is the ratio of the Electricity production(% of total) of Greece in 2003 to that in 2006?
Make the answer very short. 0.78. What is the ratio of the Electricity production(% of total) in High income in 2003 to that in 2007?
Give a very brief answer. 0.84. What is the ratio of the Electricity production(% of total) in Czech Republic in 2003 to that in 2007?
Give a very brief answer. 1.23. What is the ratio of the Electricity production(% of total) of Egypt, Arab Rep. in 2003 to that in 2007?
Your answer should be very brief. 0.96. What is the ratio of the Electricity production(% of total) in Greece in 2003 to that in 2007?
Your answer should be compact. 0.63. What is the ratio of the Electricity production(% of total) in High income in 2004 to that in 2005?
Offer a very short reply. 0.97. What is the ratio of the Electricity production(% of total) in Czech Republic in 2004 to that in 2005?
Keep it short and to the point. 1.03. What is the ratio of the Electricity production(% of total) in Greece in 2004 to that in 2005?
Offer a terse response. 1.11. What is the ratio of the Electricity production(% of total) in High income in 2004 to that in 2006?
Ensure brevity in your answer.  0.94. What is the ratio of the Electricity production(% of total) in Czech Republic in 2004 to that in 2006?
Provide a succinct answer. 0.98. What is the ratio of the Electricity production(% of total) of Egypt, Arab Rep. in 2004 to that in 2006?
Offer a very short reply. 0.99. What is the ratio of the Electricity production(% of total) in Greece in 2004 to that in 2006?
Give a very brief answer. 0.87. What is the ratio of the Electricity production(% of total) in High income in 2004 to that in 2007?
Your answer should be very brief. 0.88. What is the ratio of the Electricity production(% of total) of Czech Republic in 2004 to that in 2007?
Your answer should be very brief. 1.18. What is the ratio of the Electricity production(% of total) in Greece in 2004 to that in 2007?
Keep it short and to the point. 0.7. What is the ratio of the Electricity production(% of total) in High income in 2005 to that in 2006?
Your answer should be compact. 0.96. What is the ratio of the Electricity production(% of total) in Czech Republic in 2005 to that in 2006?
Your answer should be compact. 0.96. What is the ratio of the Electricity production(% of total) in Greece in 2005 to that in 2006?
Make the answer very short. 0.78. What is the ratio of the Electricity production(% of total) in High income in 2005 to that in 2007?
Offer a terse response. 0.91. What is the ratio of the Electricity production(% of total) in Czech Republic in 2005 to that in 2007?
Offer a very short reply. 1.15. What is the ratio of the Electricity production(% of total) of Greece in 2005 to that in 2007?
Offer a very short reply. 0.63. What is the ratio of the Electricity production(% of total) in High income in 2006 to that in 2007?
Your answer should be compact. 0.94. What is the ratio of the Electricity production(% of total) in Czech Republic in 2006 to that in 2007?
Your answer should be very brief. 1.2. What is the ratio of the Electricity production(% of total) in Egypt, Arab Rep. in 2006 to that in 2007?
Your answer should be compact. 1. What is the ratio of the Electricity production(% of total) in Greece in 2006 to that in 2007?
Ensure brevity in your answer.  0.8. What is the difference between the highest and the second highest Electricity production(% of total) in High income?
Your answer should be compact. 1.38. What is the difference between the highest and the second highest Electricity production(% of total) in Czech Republic?
Your answer should be very brief. 0.2. What is the difference between the highest and the second highest Electricity production(% of total) of Egypt, Arab Rep.?
Give a very brief answer. 0.13. What is the difference between the highest and the second highest Electricity production(% of total) of Greece?
Offer a terse response. 4.33. What is the difference between the highest and the lowest Electricity production(% of total) of High income?
Ensure brevity in your answer.  4.03. What is the difference between the highest and the lowest Electricity production(% of total) of Czech Republic?
Your answer should be very brief. 0.55. What is the difference between the highest and the lowest Electricity production(% of total) in Egypt, Arab Rep.?
Make the answer very short. 7.26. What is the difference between the highest and the lowest Electricity production(% of total) of Greece?
Your answer should be very brief. 8.88. 